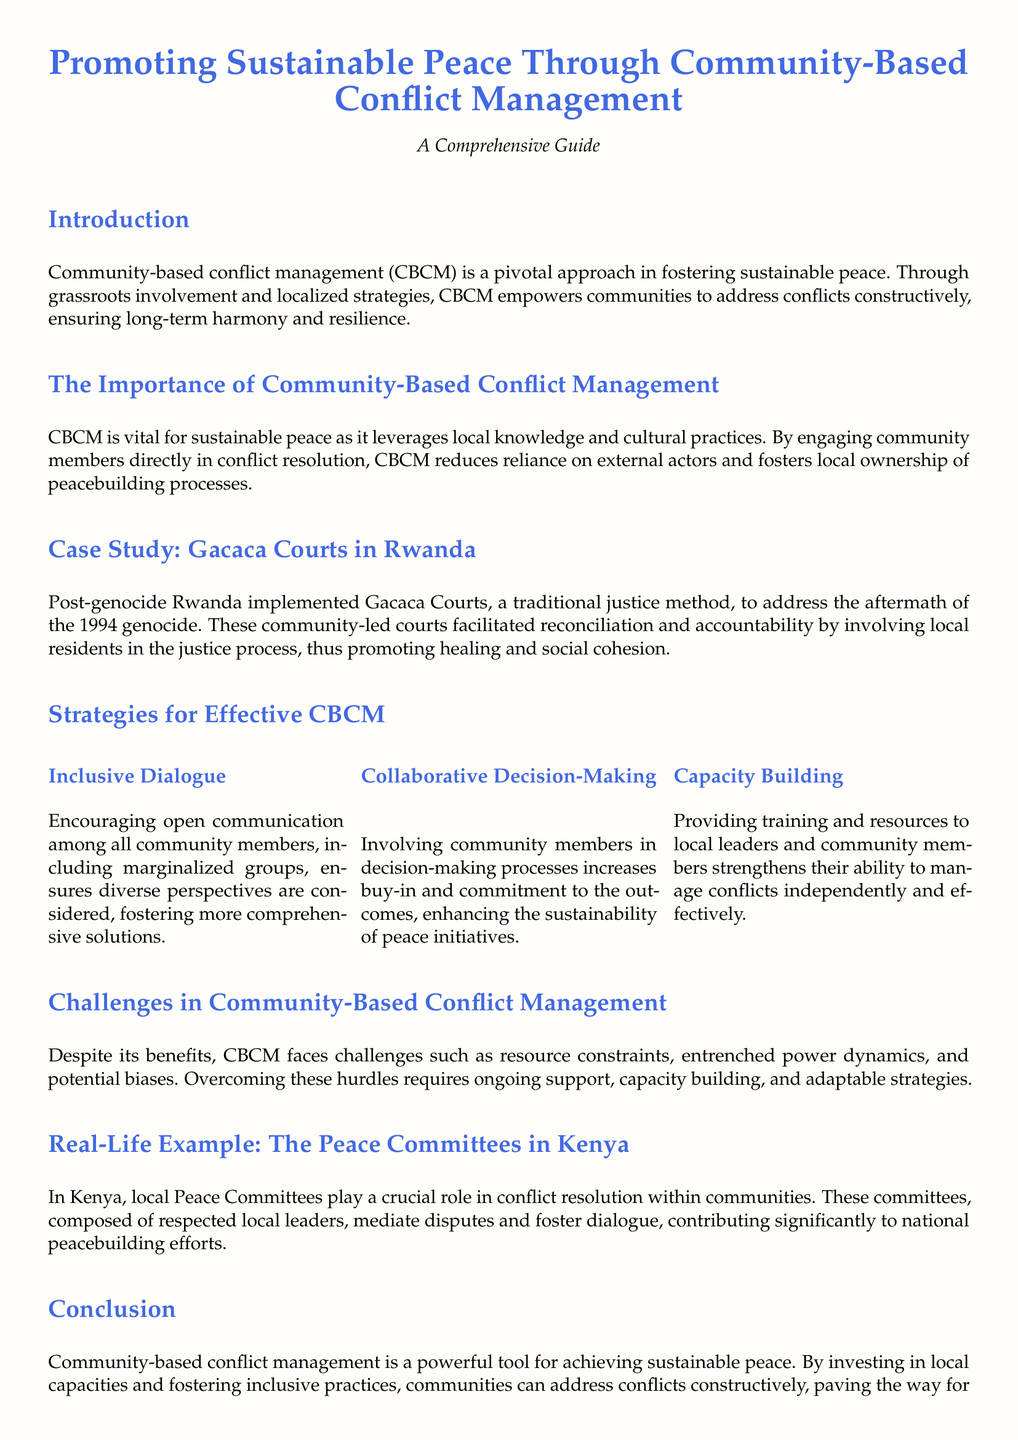What is the title of the document? The title is prominently displayed at the top of the document, indicating its main focus.
Answer: Promoting Sustainable Peace Through Community-Based Conflict Management What is the main approach discussed in the document? The document emphasizes a specific approach to peacebuilding which is detailed in the introduction.
Answer: Community-based conflict management What case study is mentioned in the document? The document provides a case study to illustrate the application of CBCM, detailing a specific historical event.
Answer: Gacaca Courts in Rwanda What is one strategy for effective community-based conflict management? The document lists strategies in a section, highlighting methods for improving conflict resolution efforts.
Answer: Inclusive Dialogue What are local Peace Committees primarily involved in? The document describes the role of these committees in a real-life example to illustrate their function.
Answer: Conflict resolution What is a significant challenge mentioned in community-based conflict management? The document outlines obstacles faced by CBCM, drawing attention to the complexities involved.
Answer: Resource constraints What type of training is highlighted as important for community members? The document discusses enhancing local capabilities, specifying types of support that are beneficial.
Answer: Capacity Building In what year did the genocide that led to the establishment of the Gacaca Courts occur? The case study provides specific historical context to this event, which is crucial for understanding the timeline.
Answer: 1994 What contributes to enhancing the sustainability of peace initiatives? The document explains how community involvement impacts the effectiveness of peacebuilding efforts.
Answer: Collaborative Decision-Making 